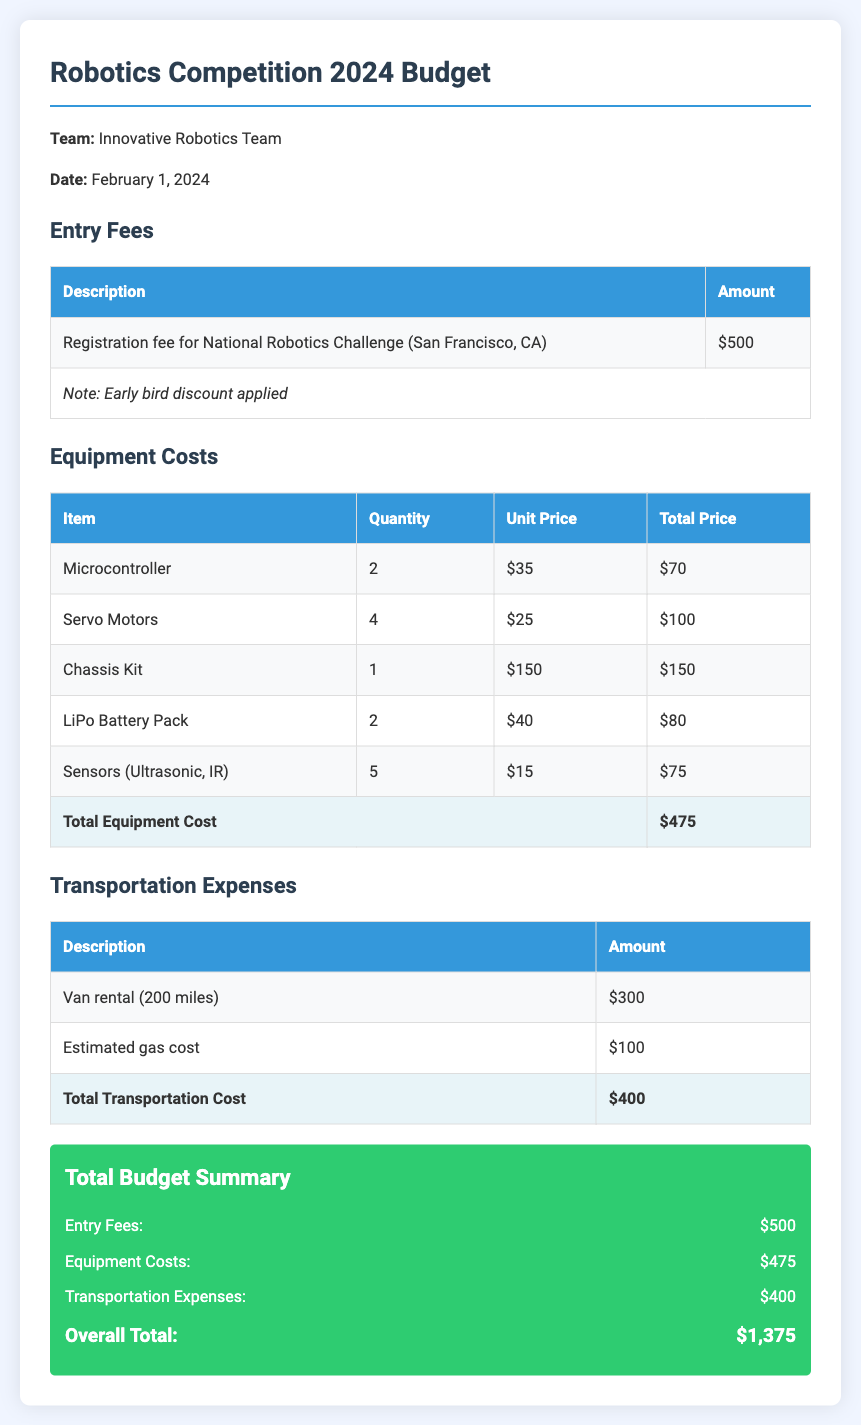What is the total equipment cost? The total equipment cost is located in the equipment costs table, which sums the individual costs to $475.
Answer: $475 What is the registration fee for the National Robotics Challenge? The registration fee can be found under entry fees, which is listed as $500.
Answer: $500 What is the estimated gas cost? The estimated gas cost is specified in the transportation expenses section as $100.
Answer: $100 How many servo motors are needed? The quantity of servo motors is provided in the equipment costs table, which states 4 are needed.
Answer: 4 What is the overall total budget? The overall total budget is summarized at the end of the document, calculated as the sum of entry fees, equipment costs, and transportation expenses, which equals $1,375.
Answer: $1,375 What is the date of the competition? The competition date is explicitly stated at the beginning of the document as February 1, 2024.
Answer: February 1, 2024 What type of team is represented in the budget? The team name is presented in the introductory section, identifying them as the Innovative Robotics Team.
Answer: Innovative Robotics Team What is the total transportation cost? The total transportation cost can be found at the bottom of the transportation expenses table, which is $400.
Answer: $400 What is the total number of LiPo battery packs needed? The equipment costs section indicates that 2 LiPo battery packs are required.
Answer: 2 